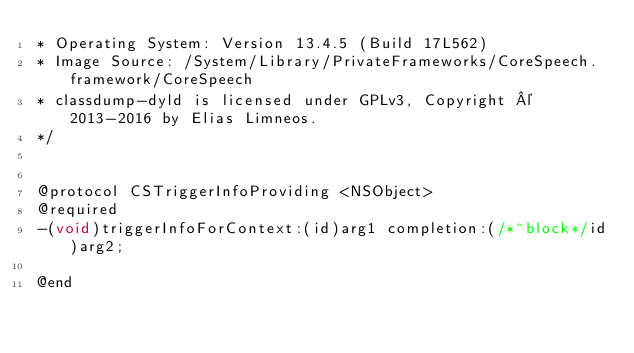Convert code to text. <code><loc_0><loc_0><loc_500><loc_500><_C_>* Operating System: Version 13.4.5 (Build 17L562)
* Image Source: /System/Library/PrivateFrameworks/CoreSpeech.framework/CoreSpeech
* classdump-dyld is licensed under GPLv3, Copyright © 2013-2016 by Elias Limneos.
*/


@protocol CSTriggerInfoProviding <NSObject>
@required
-(void)triggerInfoForContext:(id)arg1 completion:(/*^block*/id)arg2;

@end

</code> 